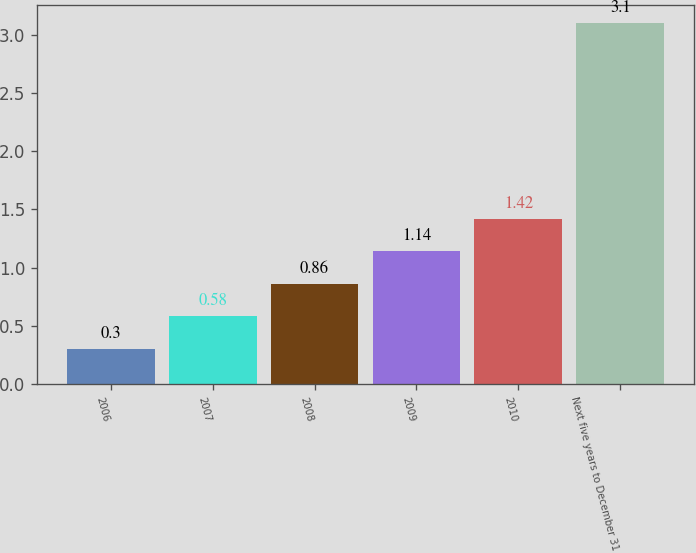Convert chart. <chart><loc_0><loc_0><loc_500><loc_500><bar_chart><fcel>2006<fcel>2007<fcel>2008<fcel>2009<fcel>2010<fcel>Next five years to December 31<nl><fcel>0.3<fcel>0.58<fcel>0.86<fcel>1.14<fcel>1.42<fcel>3.1<nl></chart> 